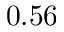<formula> <loc_0><loc_0><loc_500><loc_500>0 . 5 6</formula> 